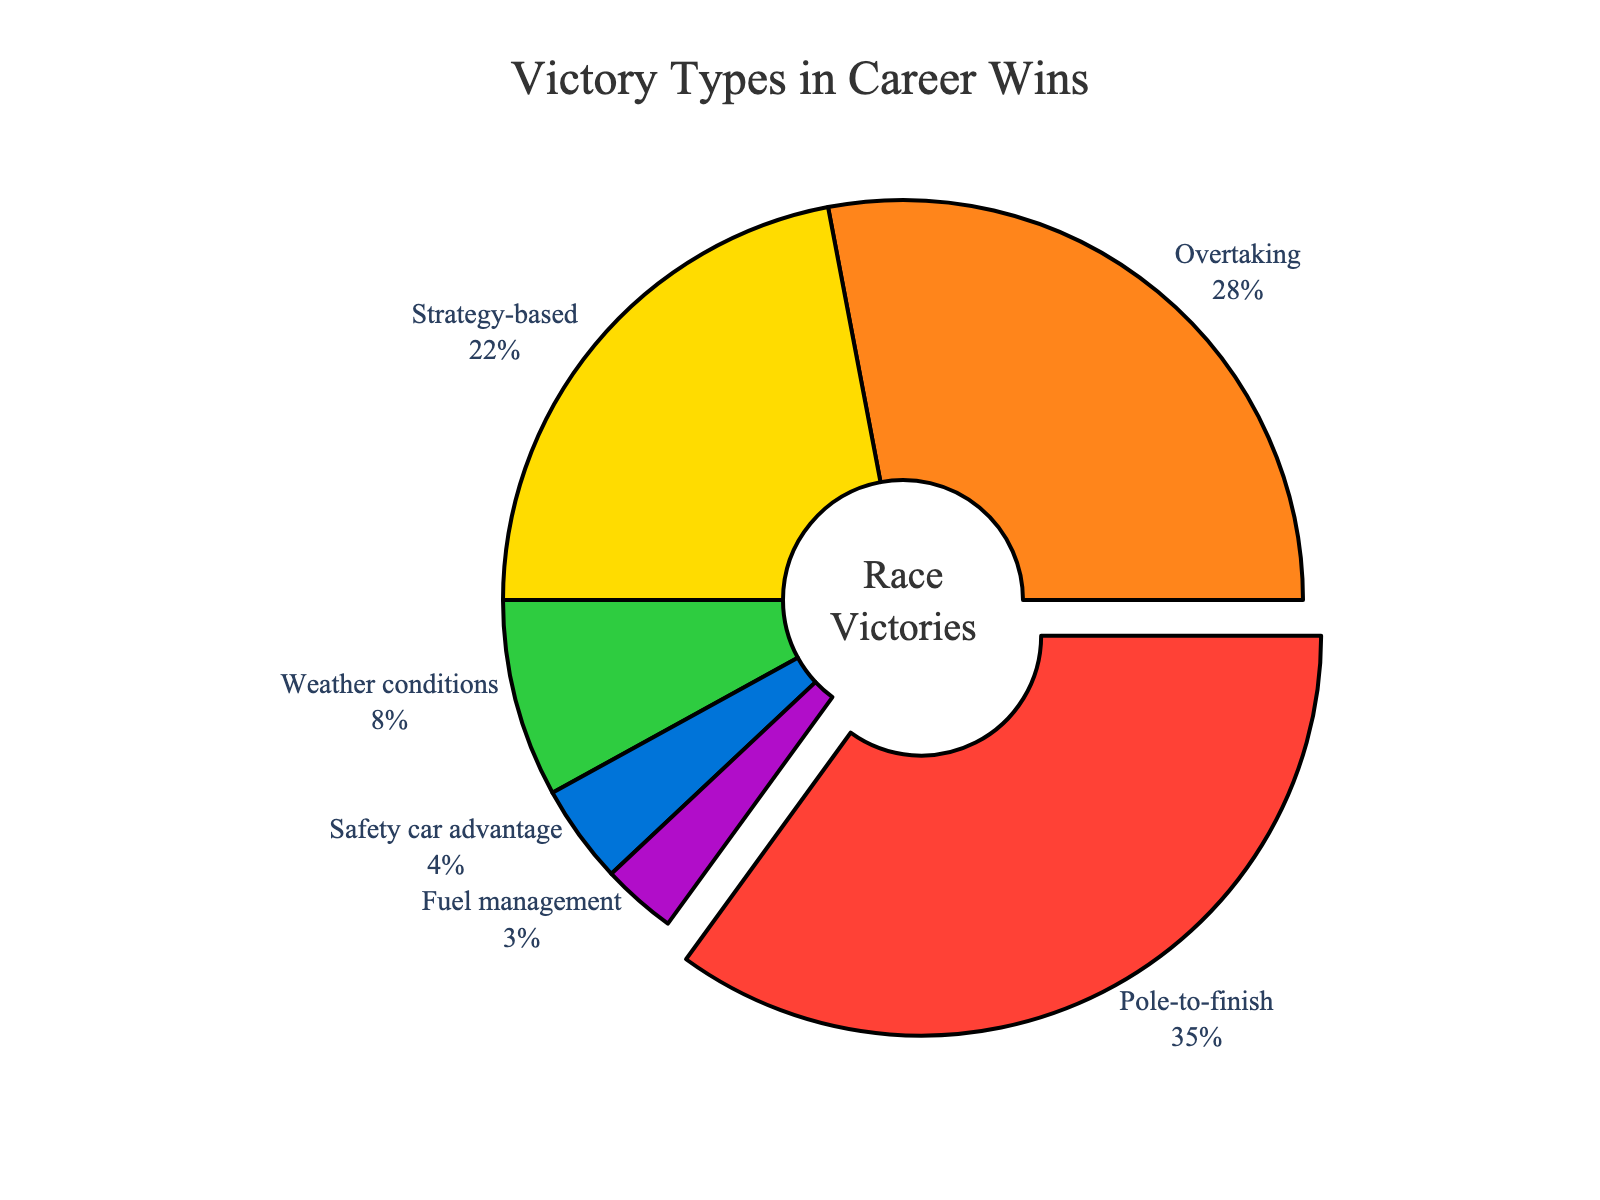What's the most common type of victory in this driver's career? The most common type of victory is identified by the largest portion of the pie chart. The 'Pole-to-finish' segment occupies the largest percentage of the chart.
Answer: Pole-to-finish Which two types of victories have the closest percentages, and what are those percentages? The percentages for 'Overtaking' and 'Strategy-based' victories are 28% and 22%, respectively. By comparing the pairs of percentages, these two types have the closest values, with a difference of only 6%.
Answer: Overtaking (28%) and Strategy-based (22%) How much more common are pole-to-finish victories compared to safety car advantage victories? The percentage for 'Pole-to-finish' is 35%, and for 'Safety car advantage' it is 4%. The difference between the two percentages indicates how much more common pole-to-finish victories are.
Answer: 31% What is the combined percentage of strategy-based and weather condition victories? Adding the percentages of 'Strategy-based' (22%) and 'Weather conditions' (8%) provides the combined value. 22% + 8% = 30%.
Answer: 30% Is the percentage of overtaking victories greater than the combined percentage of fuel management and safety car advantage victories? The percentage of 'Overtaking' victories is 28%. The combined percentage of 'Fuel management' (3%) and 'Safety car advantage' (4%) is 7%. 28% is greater than 7%.
Answer: Yes What is the total percentage of victories due to external factors (weather conditions, safety car advantage, and fuel management)? Adding the percentages for 'Weather conditions' (8%), 'Safety car advantage' (4%), and 'Fuel management' (3%) results in the total percentage. 8% + 4% + 3% = 15%.
Answer: 15% What color represents strategy-based victories in the pie chart? The color corresponding to 'Strategy-based' victories in the chart is identified by looking at the segment labeled 'Strategy-based'.
Answer: Yellow What is the visual difference between the pole-to-finish segment and the other segments in the chart? The 'Pole-to-finish' segment is slightly pulled out from the center of the pie chart to emphasize its importance. This feature differentiates it visually from the other segments.
Answer: It's pulled out Which victory type has the smallest percentage and what is that percentage? By examining the smallest section of the pie chart, the 'Fuel management' segment is identified as the smallest with a percentage of 3%.
Answer: Fuel management (3%) 